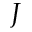<formula> <loc_0><loc_0><loc_500><loc_500>J</formula> 